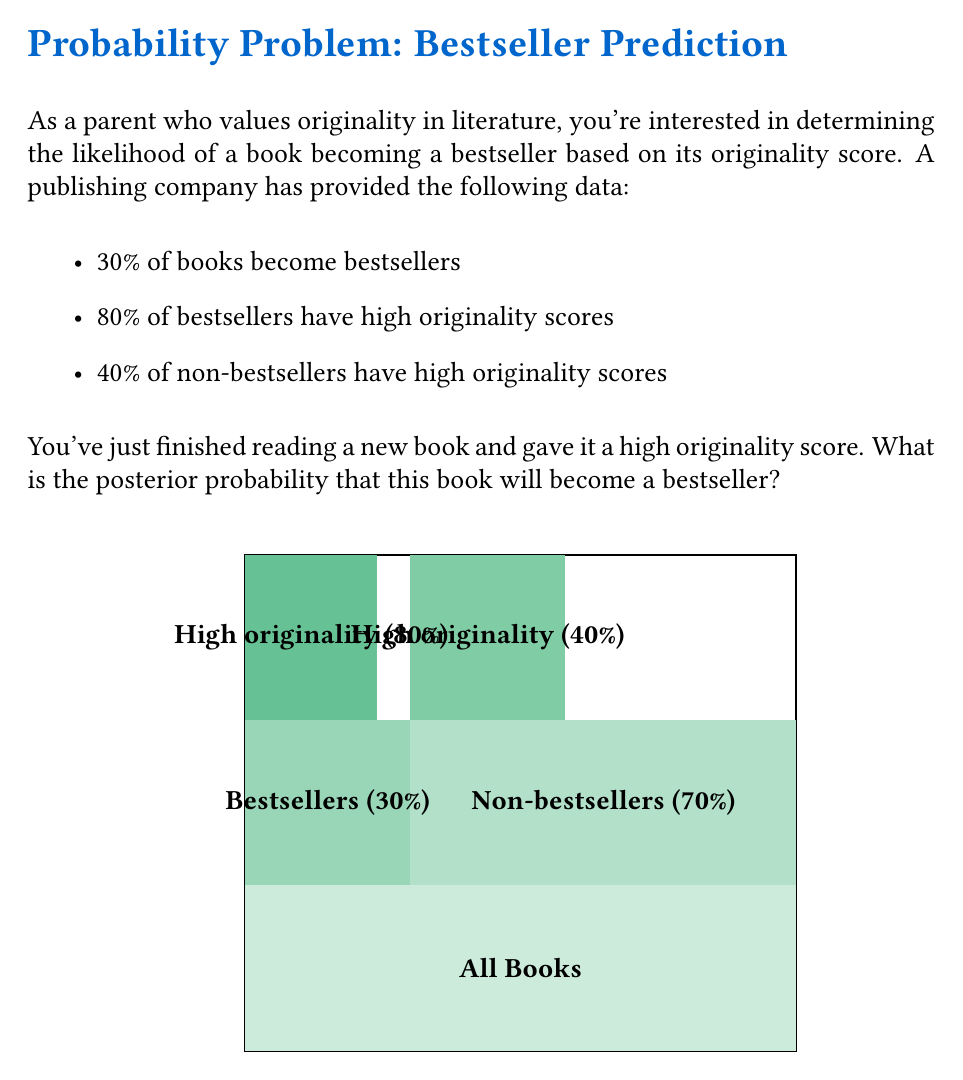Help me with this question. Let's approach this problem using Bayes' theorem. We'll define the following events:

B: The book becomes a bestseller
H: The book has a high originality score

We want to calculate $P(B|H)$, the probability that the book becomes a bestseller given that it has a high originality score.

Bayes' theorem states:

$$P(B|H) = \frac{P(H|B) \cdot P(B)}{P(H)}$$

We're given:
$P(B) = 0.30$ (30% of books become bestsellers)
$P(H|B) = 0.80$ (80% of bestsellers have high originality scores)
$P(H|\text{not }B) = 0.40$ (40% of non-bestsellers have high originality scores)

To find $P(H)$, we use the law of total probability:

$$P(H) = P(H|B) \cdot P(B) + P(H|\text{not }B) \cdot P(\text{not }B)$$

$P(\text{not }B) = 1 - P(B) = 1 - 0.30 = 0.70$

So, $P(H) = 0.80 \cdot 0.30 + 0.40 \cdot 0.70 = 0.24 + 0.28 = 0.52$

Now we can apply Bayes' theorem:

$$P(B|H) = \frac{0.80 \cdot 0.30}{0.52} = \frac{0.24}{0.52} = \frac{12}{26} \approx 0.4615$$

Therefore, the posterior probability that the book will become a bestseller, given its high originality score, is approximately 0.4615 or 46.15%.
Answer: $\frac{12}{26} \approx 0.4615$ or $46.15\%$ 